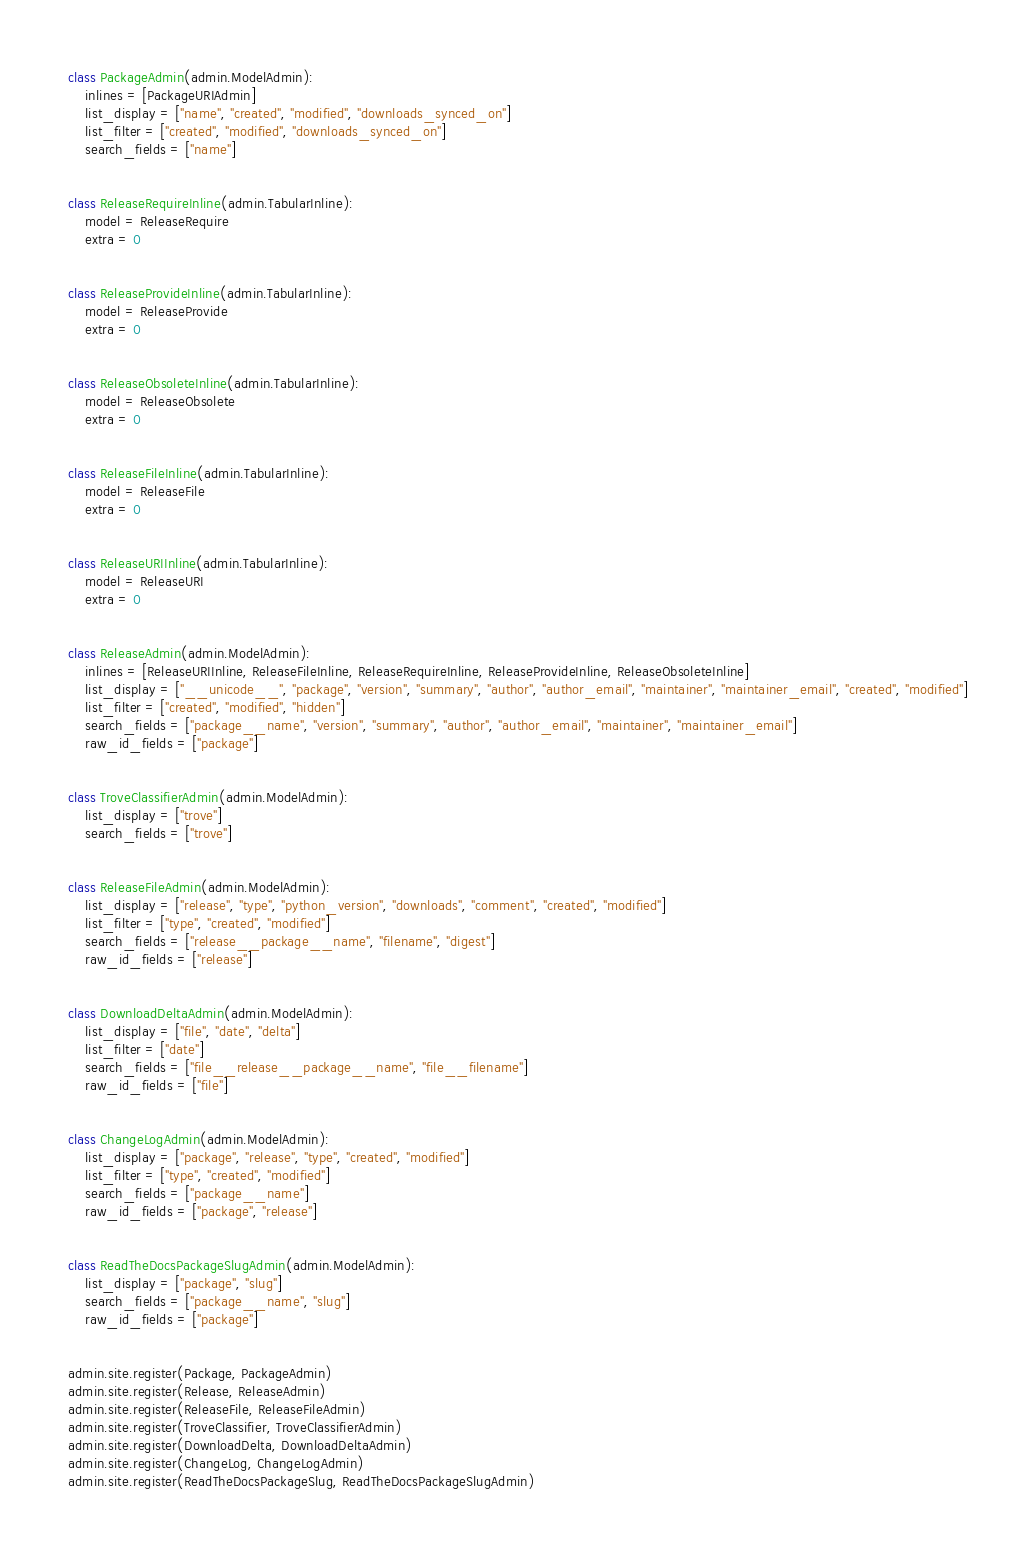Convert code to text. <code><loc_0><loc_0><loc_500><loc_500><_Python_>
class PackageAdmin(admin.ModelAdmin):
    inlines = [PackageURIAdmin]
    list_display = ["name", "created", "modified", "downloads_synced_on"]
    list_filter = ["created", "modified", "downloads_synced_on"]
    search_fields = ["name"]


class ReleaseRequireInline(admin.TabularInline):
    model = ReleaseRequire
    extra = 0


class ReleaseProvideInline(admin.TabularInline):
    model = ReleaseProvide
    extra = 0


class ReleaseObsoleteInline(admin.TabularInline):
    model = ReleaseObsolete
    extra = 0


class ReleaseFileInline(admin.TabularInline):
    model = ReleaseFile
    extra = 0


class ReleaseURIInline(admin.TabularInline):
    model = ReleaseURI
    extra = 0


class ReleaseAdmin(admin.ModelAdmin):
    inlines = [ReleaseURIInline, ReleaseFileInline, ReleaseRequireInline, ReleaseProvideInline, ReleaseObsoleteInline]
    list_display = ["__unicode__", "package", "version", "summary", "author", "author_email", "maintainer", "maintainer_email", "created", "modified"]
    list_filter = ["created", "modified", "hidden"]
    search_fields = ["package__name", "version", "summary", "author", "author_email", "maintainer", "maintainer_email"]
    raw_id_fields = ["package"]


class TroveClassifierAdmin(admin.ModelAdmin):
    list_display = ["trove"]
    search_fields = ["trove"]


class ReleaseFileAdmin(admin.ModelAdmin):
    list_display = ["release", "type", "python_version", "downloads", "comment", "created", "modified"]
    list_filter = ["type", "created", "modified"]
    search_fields = ["release__package__name", "filename", "digest"]
    raw_id_fields = ["release"]


class DownloadDeltaAdmin(admin.ModelAdmin):
    list_display = ["file", "date", "delta"]
    list_filter = ["date"]
    search_fields = ["file__release__package__name", "file__filename"]
    raw_id_fields = ["file"]


class ChangeLogAdmin(admin.ModelAdmin):
    list_display = ["package", "release", "type", "created", "modified"]
    list_filter = ["type", "created", "modified"]
    search_fields = ["package__name"]
    raw_id_fields = ["package", "release"]


class ReadTheDocsPackageSlugAdmin(admin.ModelAdmin):
    list_display = ["package", "slug"]
    search_fields = ["package__name", "slug"]
    raw_id_fields = ["package"]


admin.site.register(Package, PackageAdmin)
admin.site.register(Release, ReleaseAdmin)
admin.site.register(ReleaseFile, ReleaseFileAdmin)
admin.site.register(TroveClassifier, TroveClassifierAdmin)
admin.site.register(DownloadDelta, DownloadDeltaAdmin)
admin.site.register(ChangeLog, ChangeLogAdmin)
admin.site.register(ReadTheDocsPackageSlug, ReadTheDocsPackageSlugAdmin)
</code> 